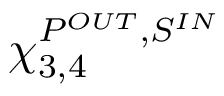<formula> <loc_0><loc_0><loc_500><loc_500>\chi _ { 3 , 4 } ^ { P ^ { O U T } , S ^ { I N } }</formula> 